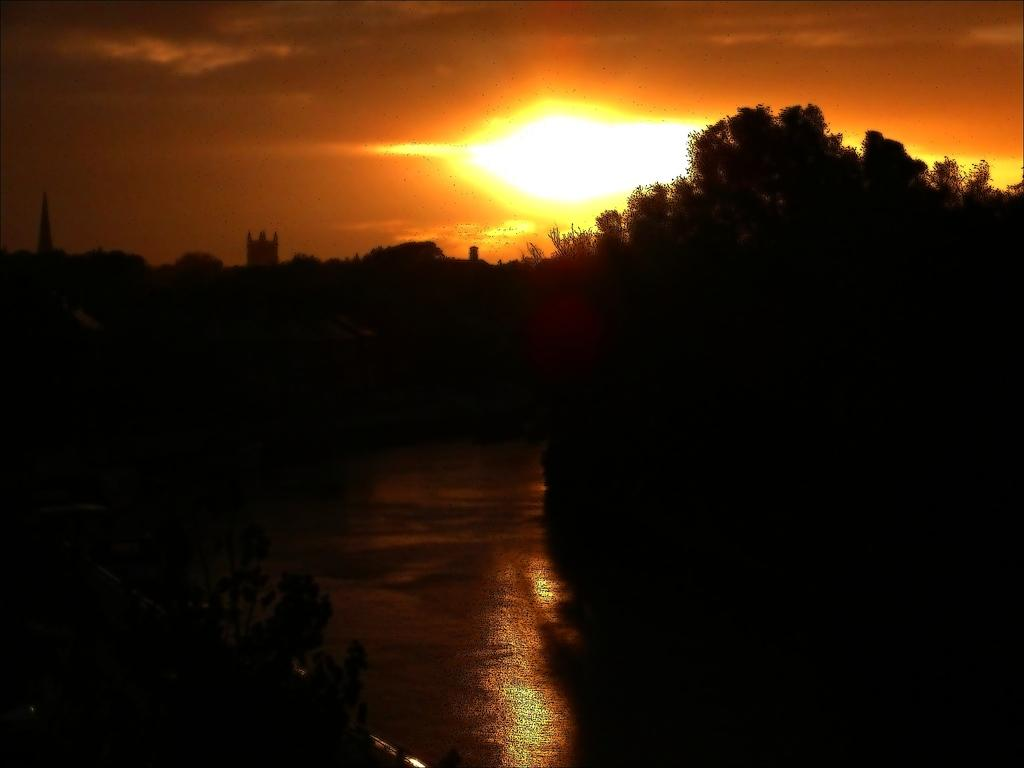What is the primary feature of the image? There is a water surface in the image. What can be seen surrounding the water surface? There are trees around the water surface. What effect can be observed on the water surface? Sun rays are reflecting on the water surface. What type of cough medicine is recommended by the guide in the image? There is no guide or cough medicine present in the image. 